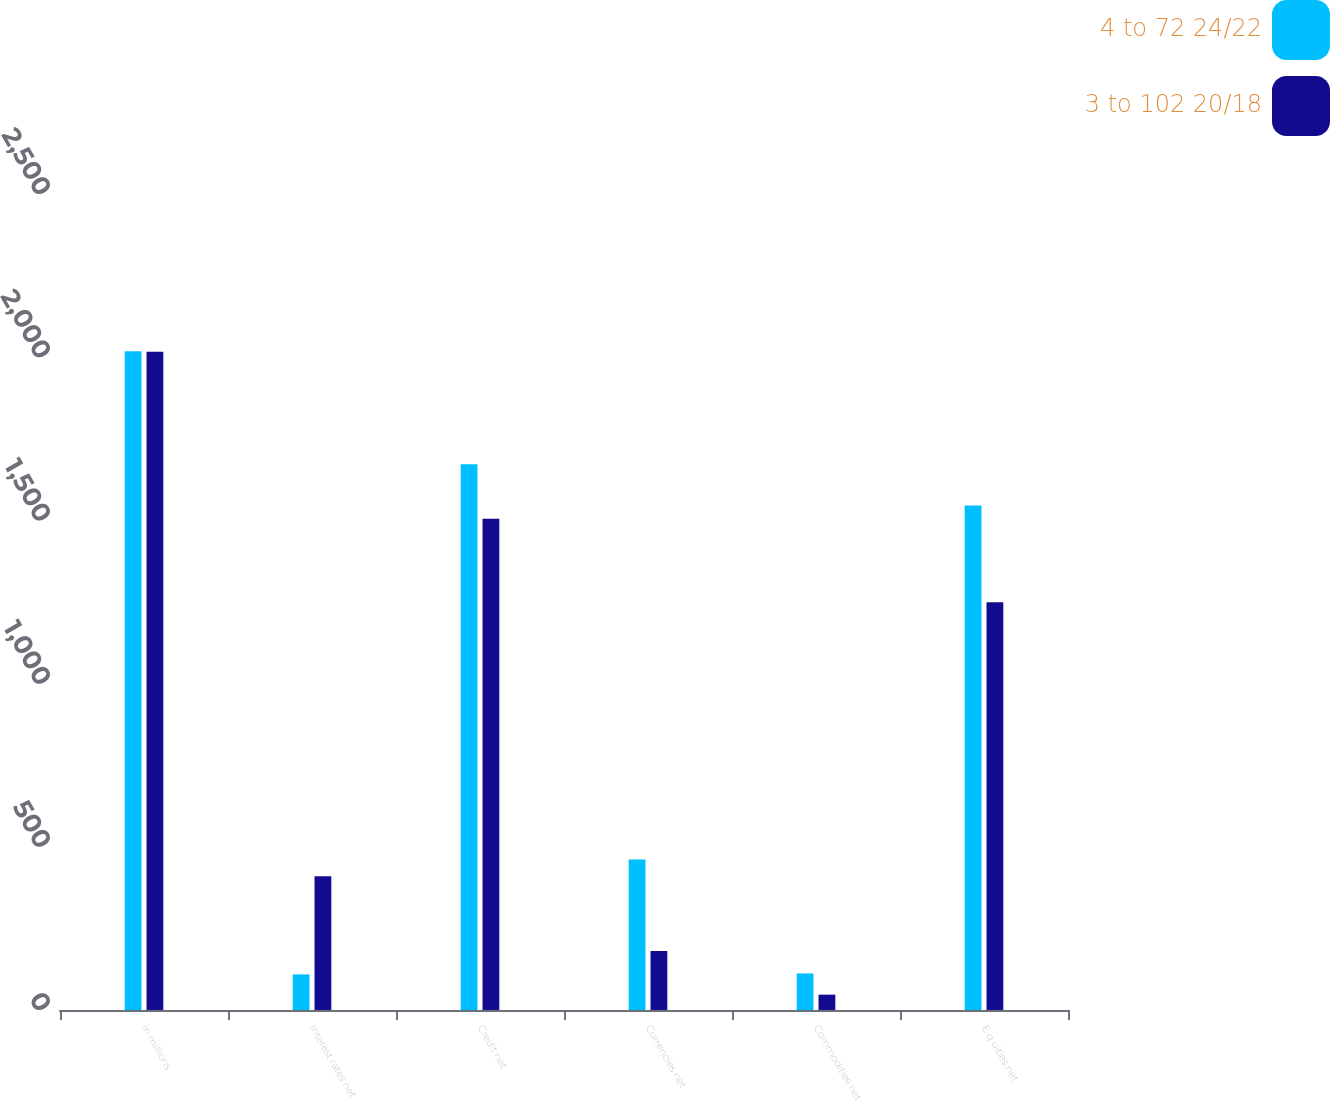<chart> <loc_0><loc_0><loc_500><loc_500><stacked_bar_chart><ecel><fcel>in millions<fcel>Interest rates net<fcel>Credit net<fcel>Currencies net<fcel>Commodities net<fcel>E q uities net<nl><fcel>4 to 72 24/22<fcel>2018<fcel>109<fcel>1672<fcel>461<fcel>112<fcel>1546<nl><fcel>3 to 102 20/18<fcel>2017<fcel>410<fcel>1505<fcel>181<fcel>47<fcel>1249<nl></chart> 